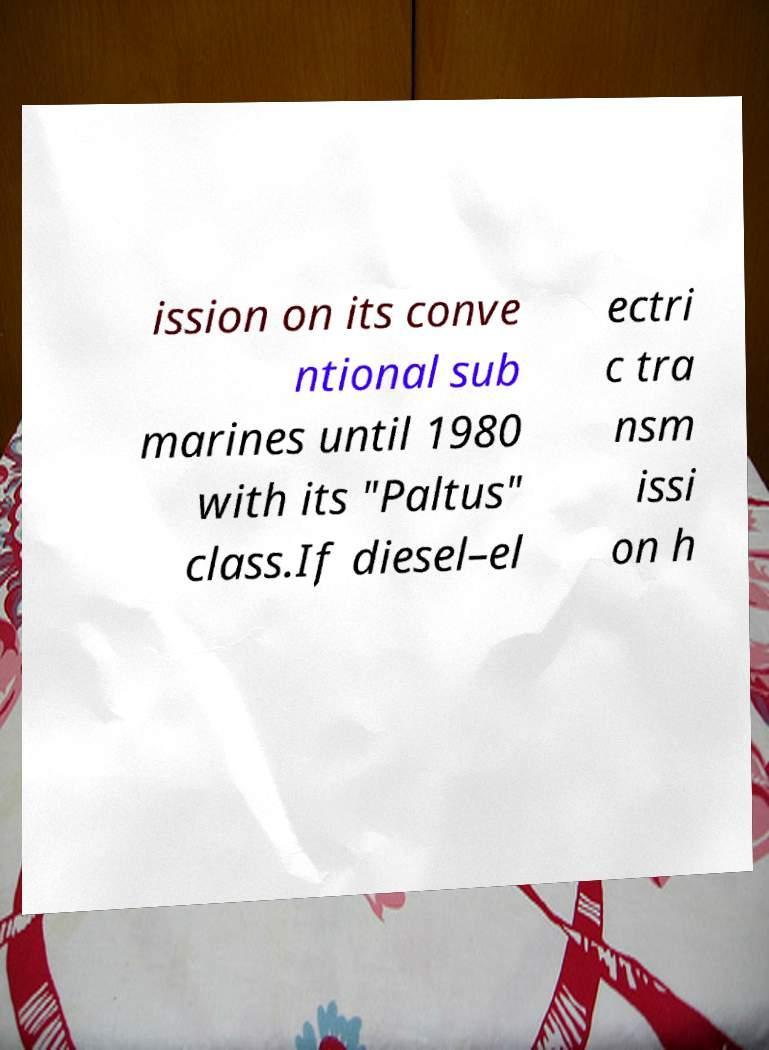What messages or text are displayed in this image? I need them in a readable, typed format. ission on its conve ntional sub marines until 1980 with its "Paltus" class.If diesel–el ectri c tra nsm issi on h 